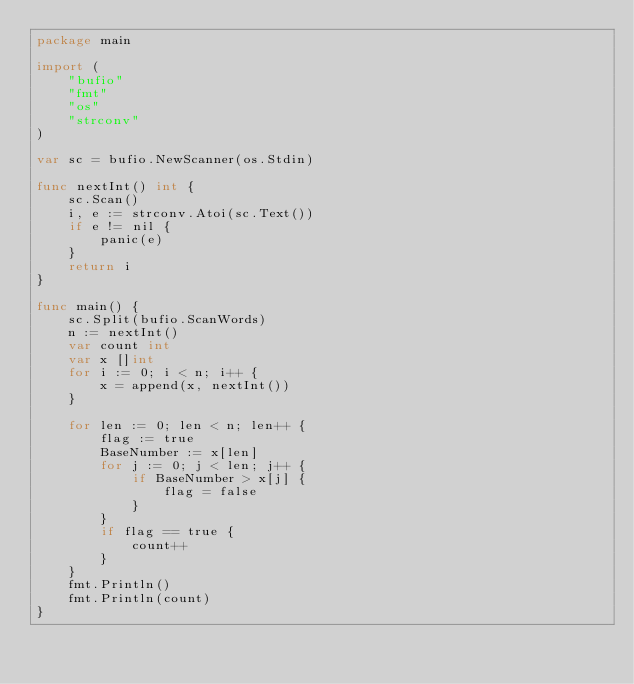<code> <loc_0><loc_0><loc_500><loc_500><_Go_>package main

import (
	"bufio"
	"fmt"
	"os"
	"strconv"
)

var sc = bufio.NewScanner(os.Stdin)

func nextInt() int {
	sc.Scan()
	i, e := strconv.Atoi(sc.Text())
	if e != nil {
		panic(e)
	}
	return i
}

func main() {
	sc.Split(bufio.ScanWords)
	n := nextInt()
	var count int
	var x []int
	for i := 0; i < n; i++ {
		x = append(x, nextInt())
	}

	for len := 0; len < n; len++ {
		flag := true
		BaseNumber := x[len]
		for j := 0; j < len; j++ {
			if BaseNumber > x[j] {
				flag = false
			}
		}
		if flag == true {
			count++
		}
	}
	fmt.Println()
	fmt.Println(count)
}
</code> 